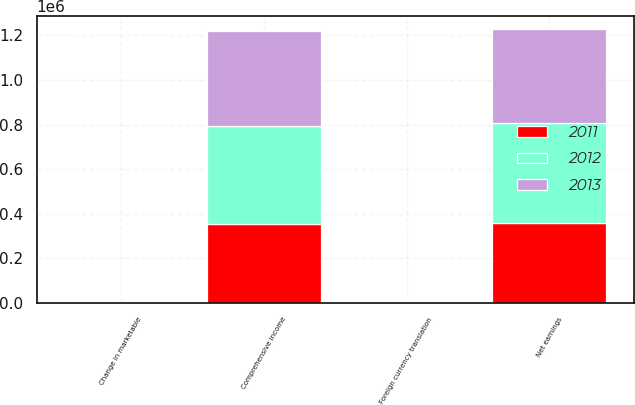Convert chart to OTSL. <chart><loc_0><loc_0><loc_500><loc_500><stacked_bar_chart><ecel><fcel>Net earnings<fcel>Foreign currency translation<fcel>Change in marketable<fcel>Comprehensive income<nl><fcel>2012<fcel>448636<fcel>7354<fcel>98<fcel>441380<nl><fcel>2013<fcel>420536<fcel>3522<fcel>39<fcel>424097<nl><fcel>2011<fcel>357929<fcel>3791<fcel>95<fcel>354233<nl></chart> 